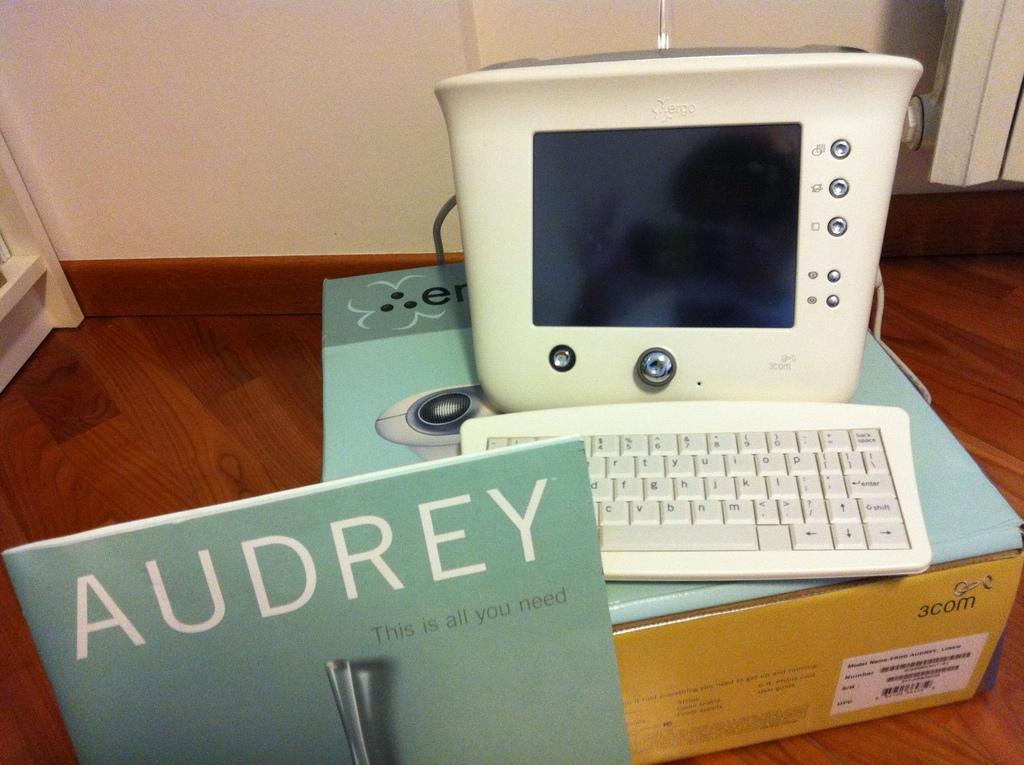What brand name is on the box?
Offer a terse response. 3com. Whose name is written above "this is all you need"?
Offer a terse response. Audrey. 